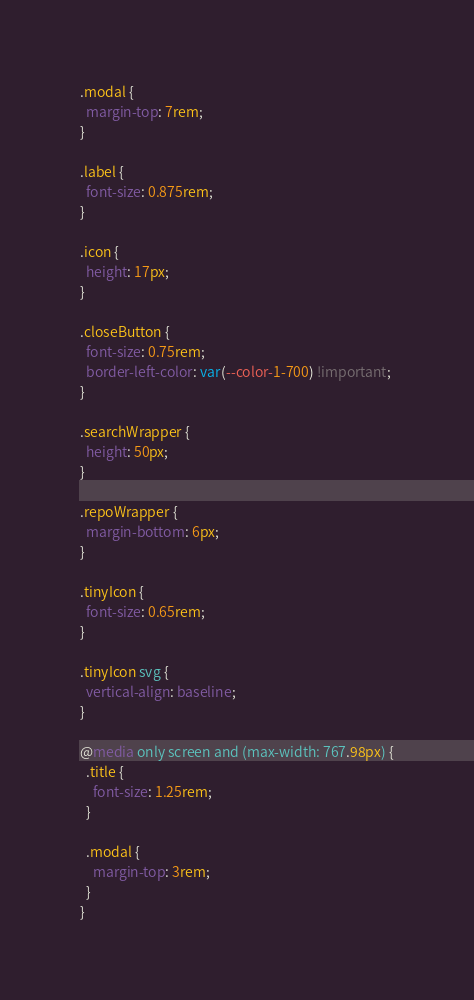Convert code to text. <code><loc_0><loc_0><loc_500><loc_500><_CSS_>.modal {
  margin-top: 7rem;
}

.label {
  font-size: 0.875rem;
}

.icon {
  height: 17px;
}

.closeButton {
  font-size: 0.75rem;
  border-left-color: var(--color-1-700) !important;
}

.searchWrapper {
  height: 50px;
}

.repoWrapper {
  margin-bottom: 6px;
}

.tinyIcon {
  font-size: 0.65rem;
}

.tinyIcon svg {
  vertical-align: baseline;
}

@media only screen and (max-width: 767.98px) {
  .title {
    font-size: 1.25rem;
  }

  .modal {
    margin-top: 3rem;
  }
}
</code> 